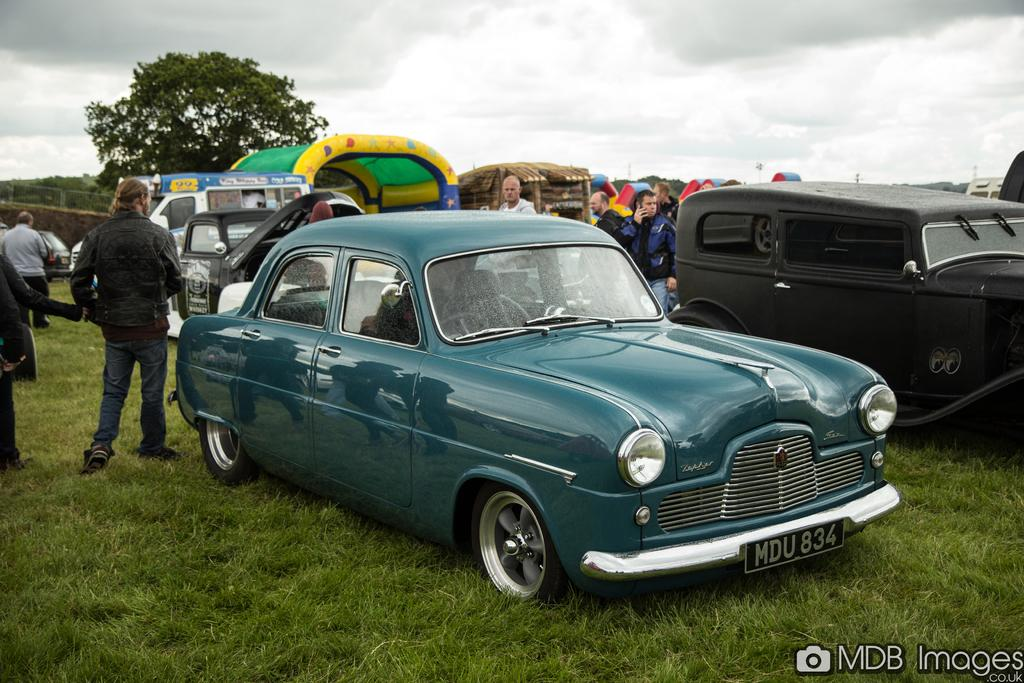Provide a one-sentence caption for the provided image. A field with parked cars including one car with number plate MDU834. 